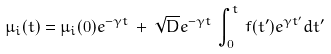Convert formula to latex. <formula><loc_0><loc_0><loc_500><loc_500>\mu _ { i } ( t ) = \mu _ { i } ( 0 ) e ^ { - \gamma t } \, + \, \sqrt { D } e ^ { - \gamma t } \, \int _ { 0 } ^ { t } \, f ( t ^ { \prime } ) e ^ { \gamma t ^ { \prime } } d t ^ { \prime }</formula> 